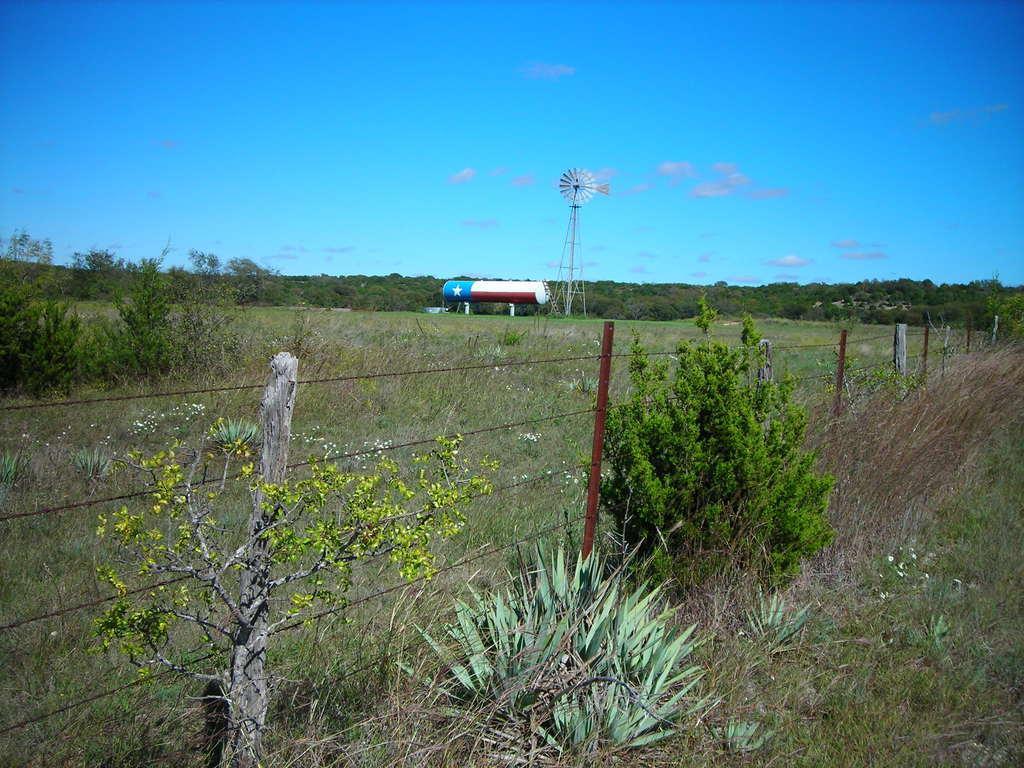Please provide a concise description of this image. In this picture we can see fence with rod, land with grass and trees and here we can see tower and a tanker with star symbol and in the background we can see bushes,sky with clouds. 